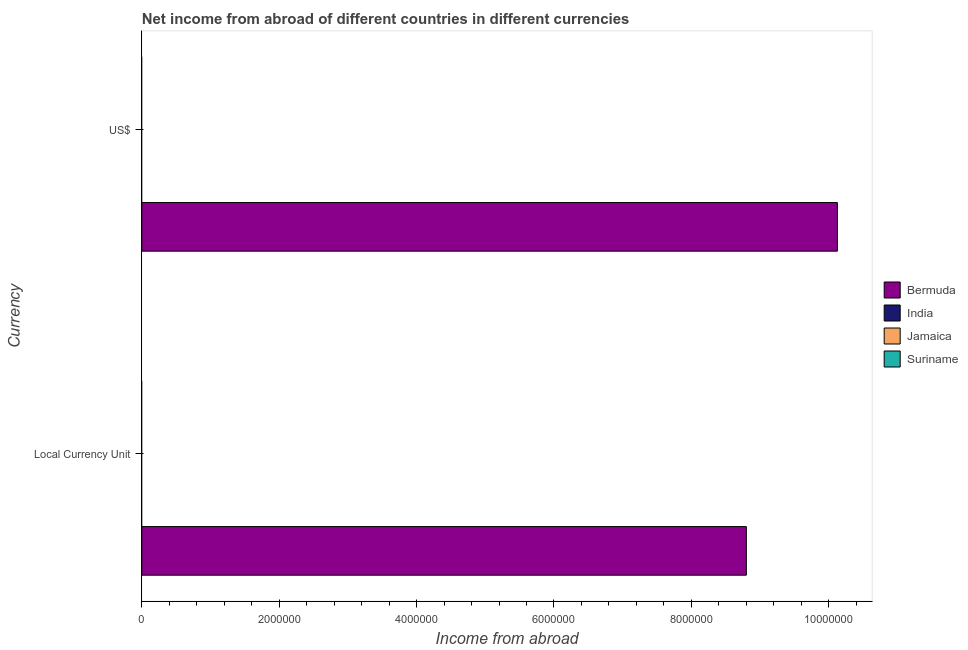Are the number of bars on each tick of the Y-axis equal?
Provide a short and direct response. Yes. What is the label of the 1st group of bars from the top?
Provide a succinct answer. US$. What is the income from abroad in us$ in Bermuda?
Your response must be concise. 1.01e+07. Across all countries, what is the maximum income from abroad in constant 2005 us$?
Provide a succinct answer. 8.80e+06. In which country was the income from abroad in constant 2005 us$ maximum?
Provide a short and direct response. Bermuda. What is the total income from abroad in us$ in the graph?
Offer a very short reply. 1.01e+07. What is the difference between the income from abroad in constant 2005 us$ in Bermuda and the income from abroad in us$ in Suriname?
Provide a succinct answer. 8.80e+06. What is the average income from abroad in constant 2005 us$ per country?
Offer a terse response. 2.20e+06. What is the difference between the income from abroad in us$ and income from abroad in constant 2005 us$ in Bermuda?
Offer a very short reply. 1.33e+06. In how many countries, is the income from abroad in constant 2005 us$ greater than the average income from abroad in constant 2005 us$ taken over all countries?
Your response must be concise. 1. How many bars are there?
Provide a succinct answer. 2. How many countries are there in the graph?
Keep it short and to the point. 4. Does the graph contain grids?
Your response must be concise. No. Where does the legend appear in the graph?
Your response must be concise. Center right. What is the title of the graph?
Offer a terse response. Net income from abroad of different countries in different currencies. Does "United Arab Emirates" appear as one of the legend labels in the graph?
Offer a terse response. No. What is the label or title of the X-axis?
Keep it short and to the point. Income from abroad. What is the label or title of the Y-axis?
Offer a very short reply. Currency. What is the Income from abroad in Bermuda in Local Currency Unit?
Offer a terse response. 8.80e+06. What is the Income from abroad of India in Local Currency Unit?
Offer a very short reply. 0. What is the Income from abroad in Bermuda in US$?
Your answer should be compact. 1.01e+07. What is the Income from abroad in India in US$?
Keep it short and to the point. 0. Across all Currency, what is the maximum Income from abroad in Bermuda?
Keep it short and to the point. 1.01e+07. Across all Currency, what is the minimum Income from abroad of Bermuda?
Keep it short and to the point. 8.80e+06. What is the total Income from abroad in Bermuda in the graph?
Give a very brief answer. 1.89e+07. What is the total Income from abroad in Jamaica in the graph?
Provide a succinct answer. 0. What is the total Income from abroad of Suriname in the graph?
Offer a very short reply. 0. What is the difference between the Income from abroad of Bermuda in Local Currency Unit and that in US$?
Your answer should be very brief. -1.33e+06. What is the average Income from abroad in Bermuda per Currency?
Your answer should be very brief. 9.46e+06. What is the average Income from abroad of Jamaica per Currency?
Your answer should be very brief. 0. What is the average Income from abroad in Suriname per Currency?
Ensure brevity in your answer.  0. What is the ratio of the Income from abroad of Bermuda in Local Currency Unit to that in US$?
Offer a very short reply. 0.87. What is the difference between the highest and the second highest Income from abroad of Bermuda?
Make the answer very short. 1.33e+06. What is the difference between the highest and the lowest Income from abroad of Bermuda?
Your answer should be very brief. 1.33e+06. 